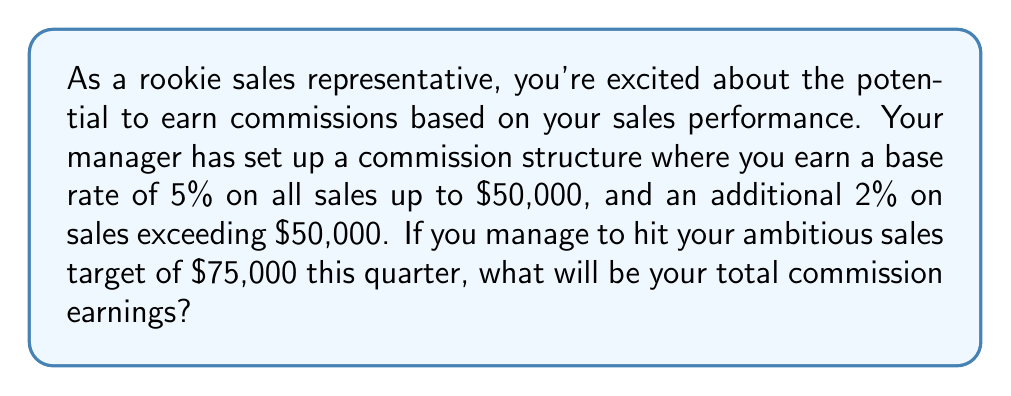Could you help me with this problem? Let's break this problem down step-by-step:

1. Understand the commission structure:
   - 5% on sales up to $50,000
   - Additional 2% on sales exceeding $50,000

2. Calculate the commission on the first $50,000:
   $$ \text{Commission}_1 = $50,000 \times 5\% = $50,000 \times 0.05 = $2,500 $$

3. Calculate the commission on the sales exceeding $50,000:
   - Amount exceeding $50,000: $75,000 - $50,000 = $25,000
   $$ \text{Commission}_2 = $25,000 \times 2\% = $25,000 \times 0.02 = $500 $$

4. Sum up the total commission:
   $$ \text{Total Commission} = \text{Commission}_1 + \text{Commission}_2 $$
   $$ \text{Total Commission} = $2,500 + $500 = $3,000 $$

Therefore, if you hit your sales target of $75,000, your total commission earnings will be $3,000.
Answer: $3,000 